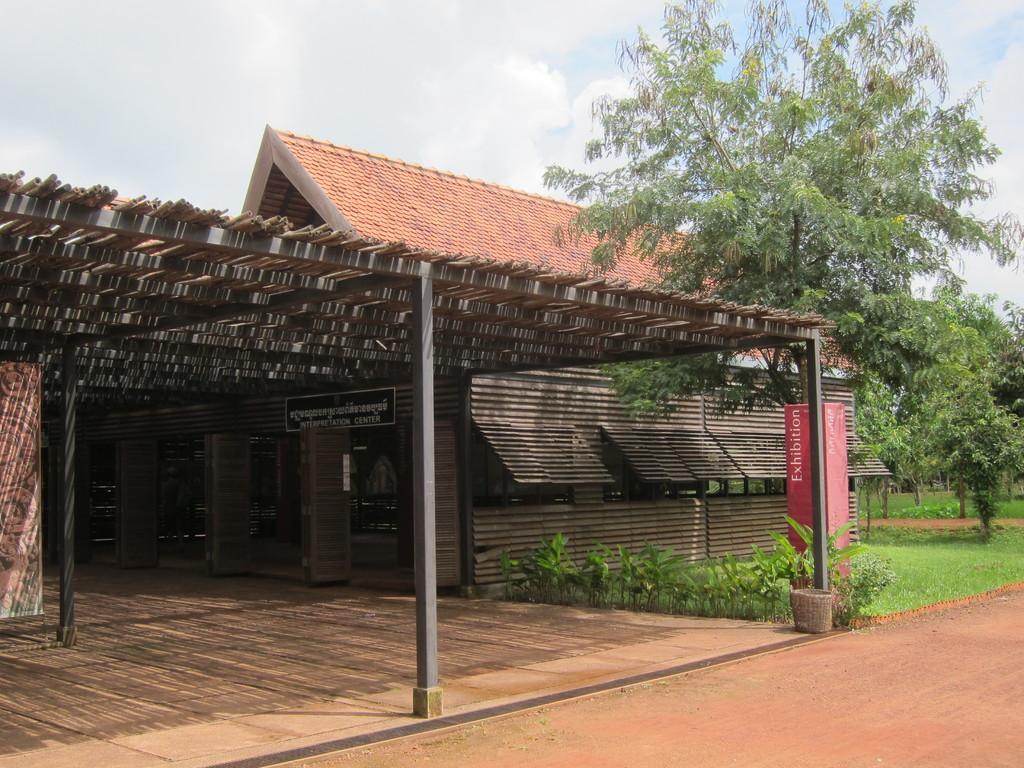Could you give a brief overview of what you see in this image? In this picture we can see a house, name board, pillars, plants, trees, grass, path and in the background we can see the sky with clouds. 